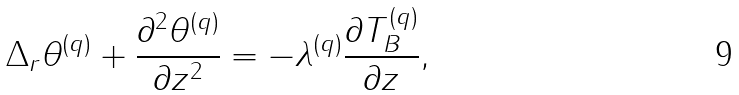<formula> <loc_0><loc_0><loc_500><loc_500>\Delta _ { r } \theta ^ { ( q ) } + \frac { \partial ^ { 2 } \theta ^ { ( q ) } } { \partial z ^ { 2 } } = - \lambda ^ { ( q ) } \frac { \partial T _ { B } ^ { ( q ) } } { \partial z } ,</formula> 